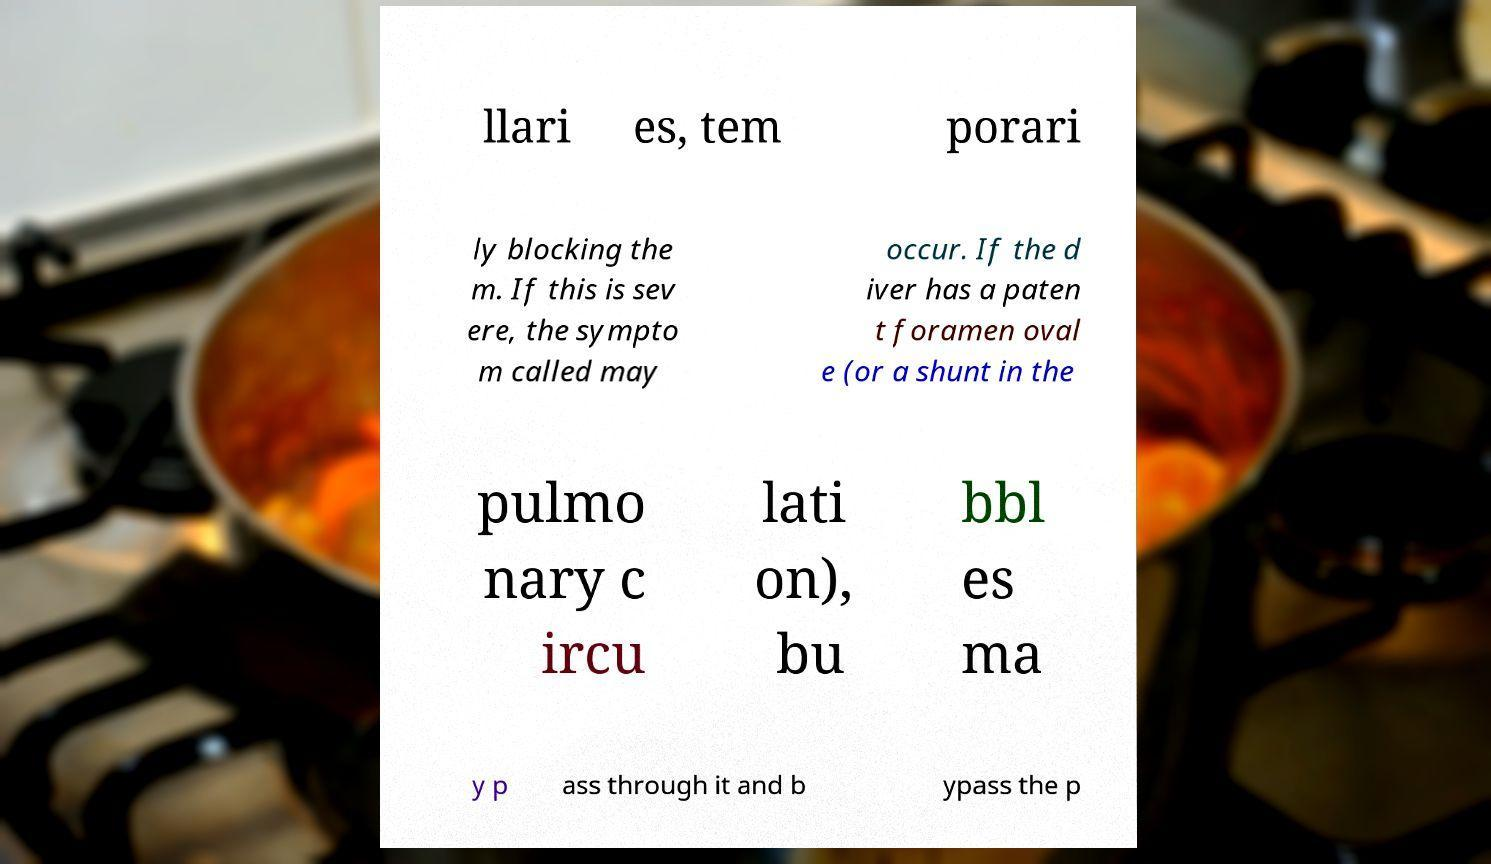There's text embedded in this image that I need extracted. Can you transcribe it verbatim? llari es, tem porari ly blocking the m. If this is sev ere, the sympto m called may occur. If the d iver has a paten t foramen oval e (or a shunt in the pulmo nary c ircu lati on), bu bbl es ma y p ass through it and b ypass the p 